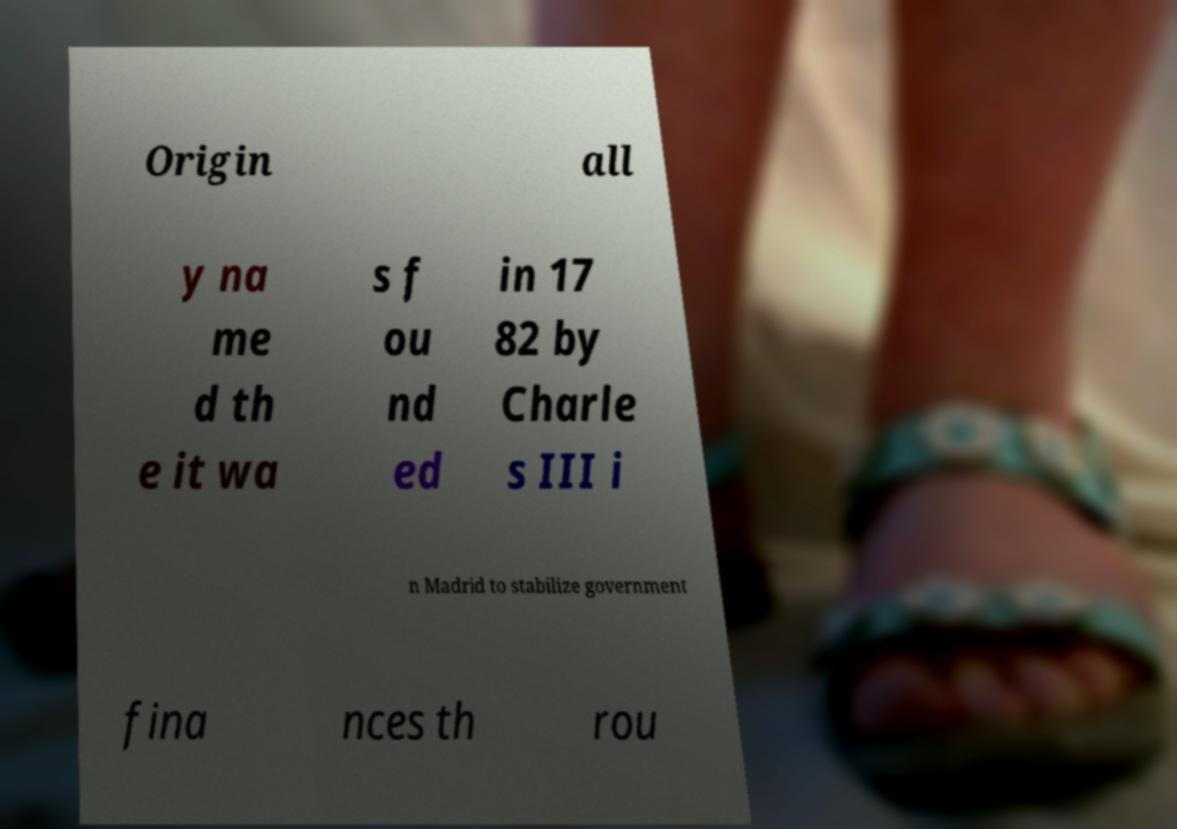For documentation purposes, I need the text within this image transcribed. Could you provide that? Origin all y na me d th e it wa s f ou nd ed in 17 82 by Charle s III i n Madrid to stabilize government fina nces th rou 